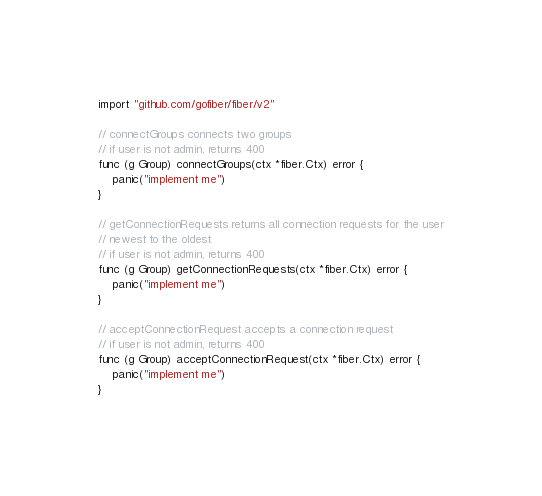<code> <loc_0><loc_0><loc_500><loc_500><_Go_>
import "github.com/gofiber/fiber/v2"

// connectGroups connects two groups
// if user is not admin, returns 400
func (g Group) connectGroups(ctx *fiber.Ctx) error {
	panic("implement me")
}

// getConnectionRequests returns all connection requests for the user
// newest to the oldest
// if user is not admin, returns 400
func (g Group) getConnectionRequests(ctx *fiber.Ctx) error {
	panic("implement me")
}

// acceptConnectionRequest accepts a connection request
// if user is not admin, returns 400
func (g Group) acceptConnectionRequest(ctx *fiber.Ctx) error {
	panic("implement me")
}
</code> 